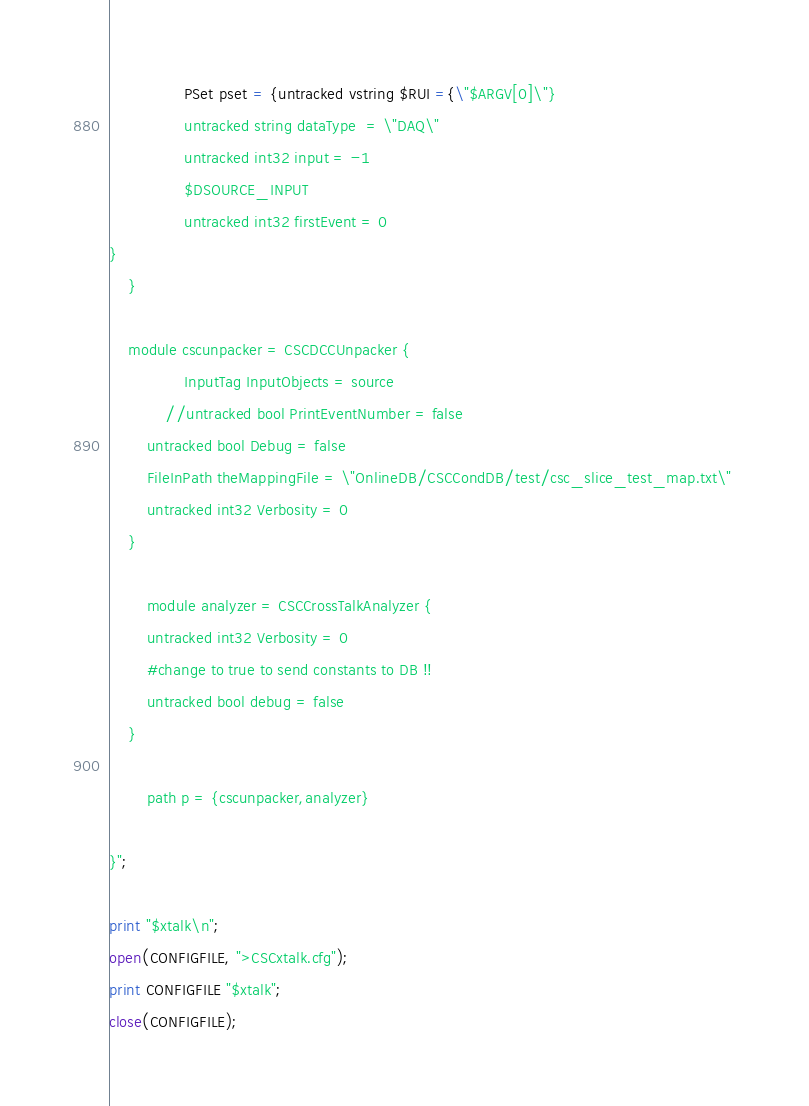Convert code to text. <code><loc_0><loc_0><loc_500><loc_500><_Perl_>               	PSet pset = {untracked vstring $RUI ={\"$ARGV[0]\"}
                untracked string dataType  = \"DAQ\"
                untracked int32 input = -1
                $DSOURCE_INPUT
                untracked int32 firstEvent = 0
}
	}

	module cscunpacker = CSCDCCUnpacker {
                InputTag InputObjects = source
        	//untracked bool PrintEventNumber = false
		untracked bool Debug = false
		FileInPath theMappingFile = \"OnlineDB/CSCCondDB/test/csc_slice_test_map.txt\" 
		untracked int32 Verbosity = 0
	} 

        module analyzer = CSCCrossTalkAnalyzer {
 		untracked int32 Verbosity = 0
		#change to true to send constants to DB !!
		untracked bool debug = false
	}

       	path p = {cscunpacker,analyzer}

}";

print "$xtalk\n"; 
open(CONFIGFILE, ">CSCxtalk.cfg");
print CONFIGFILE "$xtalk";
close(CONFIGFILE); 
</code> 